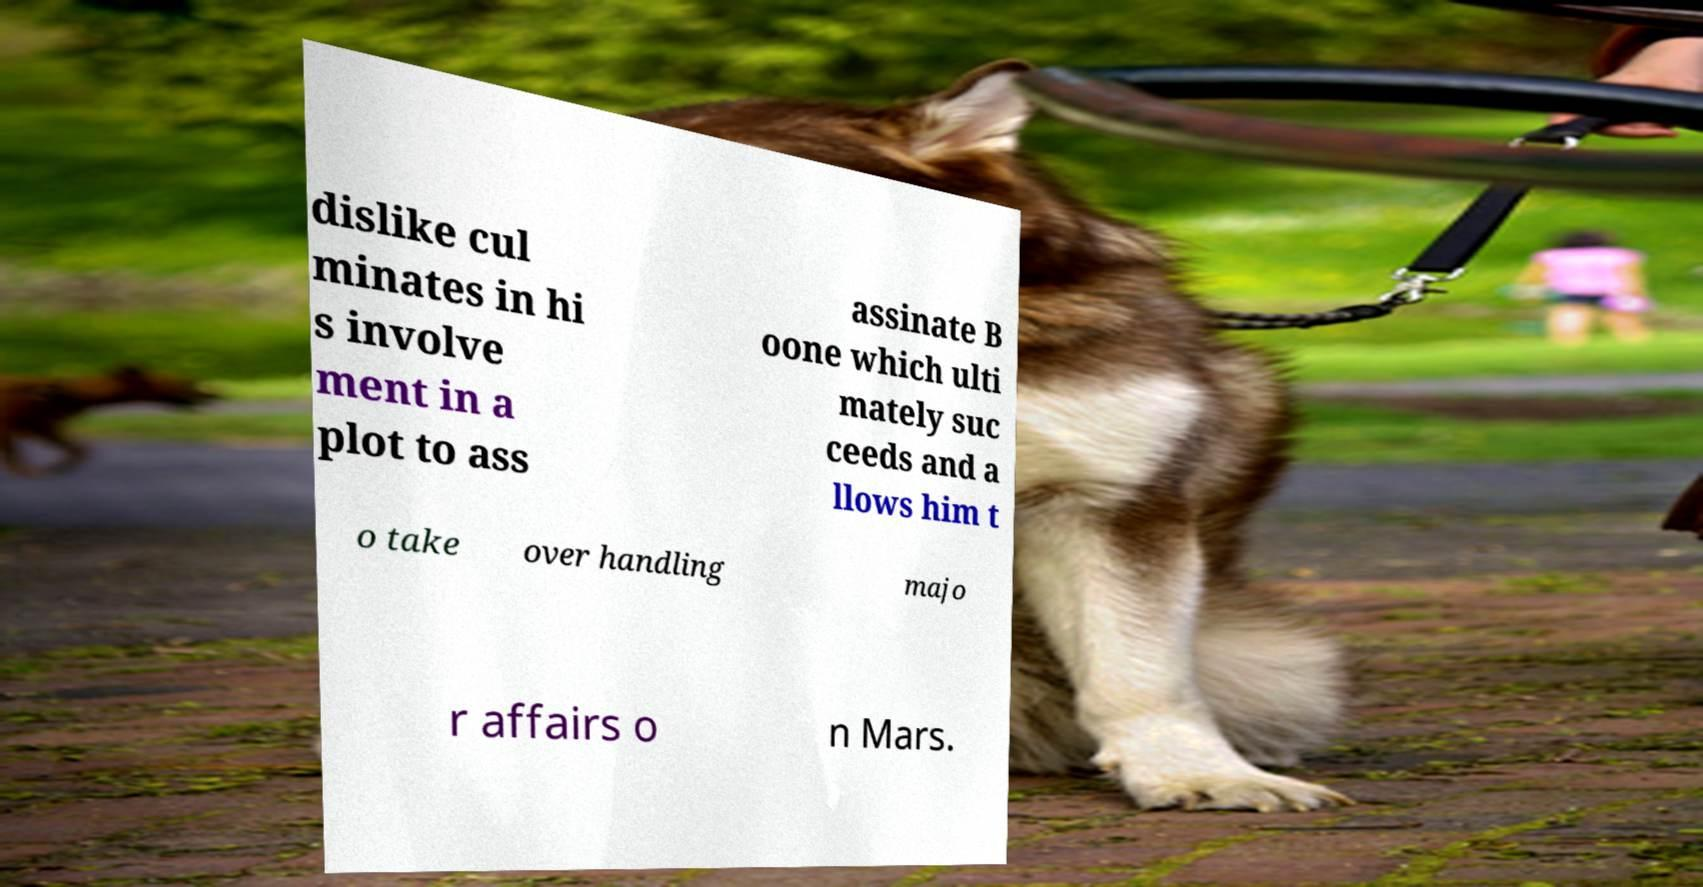Could you extract and type out the text from this image? dislike cul minates in hi s involve ment in a plot to ass assinate B oone which ulti mately suc ceeds and a llows him t o take over handling majo r affairs o n Mars. 